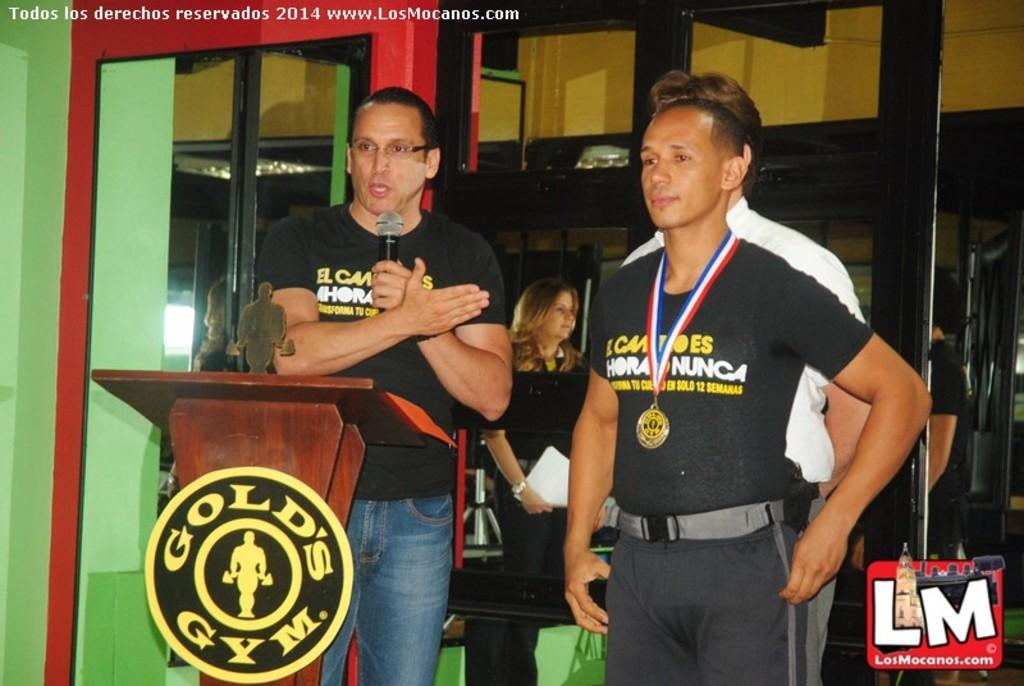Provide a one-sentence caption for the provided image. Two men speaking in front of a podium which says Gold's Gym. 